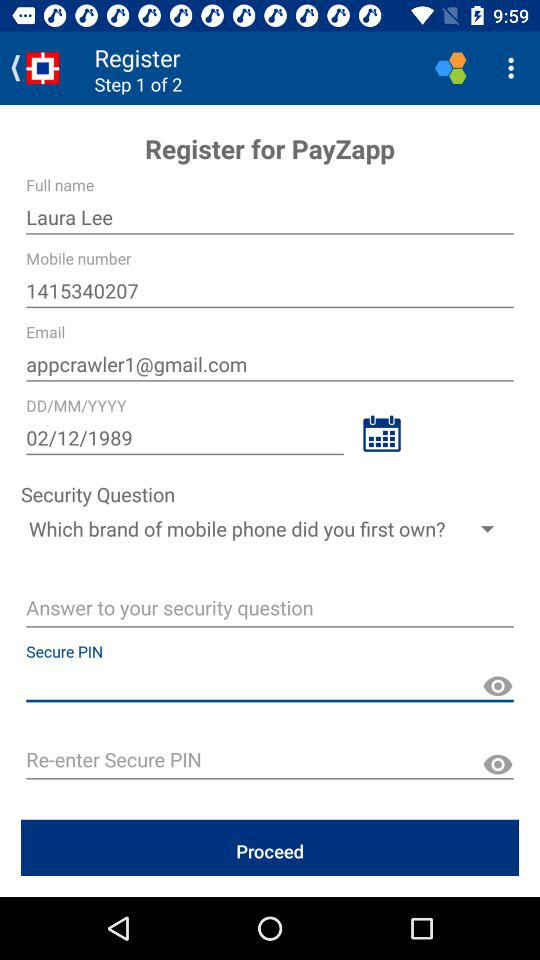What's the full name? The full name is Laura Lee. 